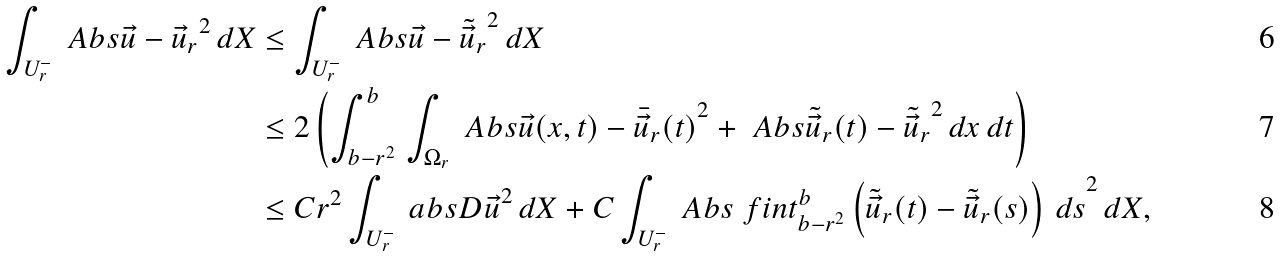Convert formula to latex. <formula><loc_0><loc_0><loc_500><loc_500>\int _ { U ^ { - } _ { r } } \ A b s { \vec { u } - \vec { u } _ { r } } ^ { 2 } \, d X & \leq \int _ { U ^ { - } _ { r } } \ A b s { \vec { u } - \tilde { \vec { u } } _ { r } } ^ { 2 } \, d X \\ & \leq 2 \left ( \int _ { b - r ^ { 2 } } ^ { b } \, \int _ { \Omega _ { r } } \ A b s { \vec { u } ( x , t ) - \bar { \vec { u } } _ { r } ( t ) } ^ { 2 } + \ A b s { \tilde { \vec { u } } _ { r } ( t ) - \tilde { \vec { u } } _ { r } } ^ { 2 } \, d x \, d t \right ) \\ & \leq C r ^ { 2 } \int _ { U ^ { - } _ { r } } \ a b s { D \vec { u } } ^ { 2 } \, d X + C \int _ { U ^ { - } _ { r } } \ A b s { \ f i n t _ { b - r ^ { 2 } } ^ { b } \left ( \tilde { \vec { u } } _ { r } ( t ) - \tilde { \vec { u } } _ { r } ( s ) \right ) \, d s } ^ { 2 } \, d X ,</formula> 